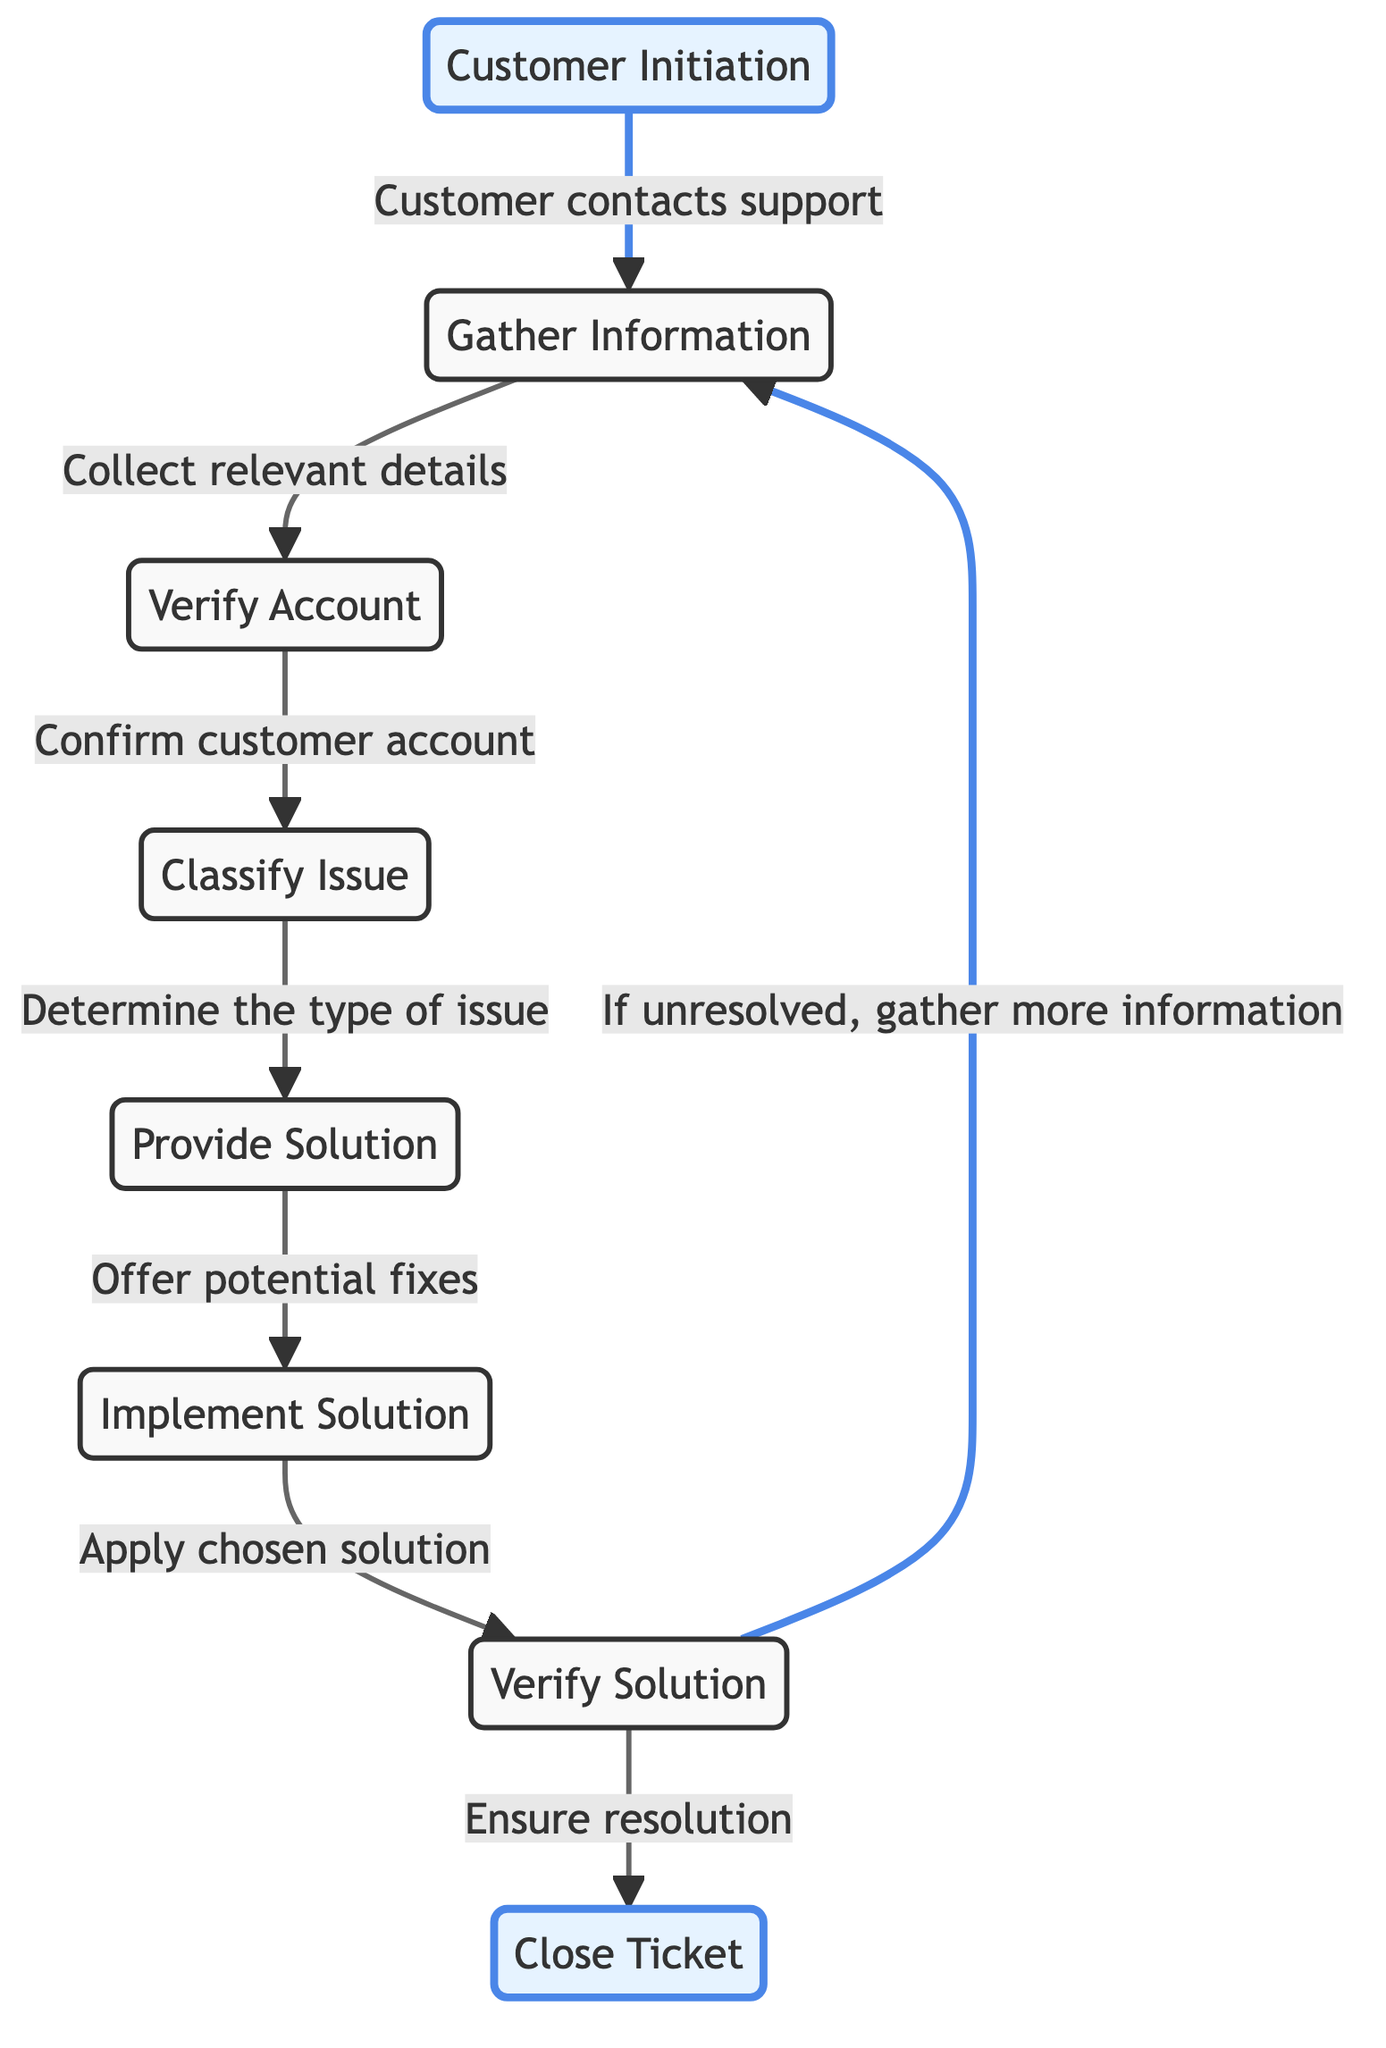What is the starting point of the workflow? The workflow begins with the "Customer Initiation" node, indicating that the customer initiates the contact with support.
Answer: Customer Initiation How many nodes are in the diagram? By counting all distinct nodes listed, we find a total of eight nodes representing various steps in the workflow.
Answer: 8 What is the first action taken after customer initiation? After "Customer Initiation," the next action is to "Gather Information," which is indicated by the directed edge connecting these two nodes.
Answer: Gather Information Which node directly follows "Provide Solution"? The node that follows "Provide Solution" is "Implement Solution" as indicated in the directed connection in the workflow.
Answer: Implement Solution What happens if the solution is not resolved? If the solution is not resolved, the workflow directs back to "Gather Information," indicating a repeat in this phase to collect more relevant details.
Answer: Gather more information How many edges are present in the diagram? Counting the edges (connections between nodes), we find there are a total of eight edges that represent the transitions between each step in the workflow.
Answer: 8 What are the two alternative outcomes after "Verify Solution"? After "Verify Solution," there are two possible paths: either "Close Ticket" if the issue is resolved, or return to "Gather Information" if the issue remains unresolved.
Answer: Close Ticket, Gather more information What determines the type of issue? The "Classify Issue" node is responsible for determining the type of issue based on gathered information and the verification of the account.
Answer: Classify Issue Which step confirms customer account details? The step that confirms customer account details is "Verify Account," which follows the gathering of necessary information before classifying the issue.
Answer: Verify Account 